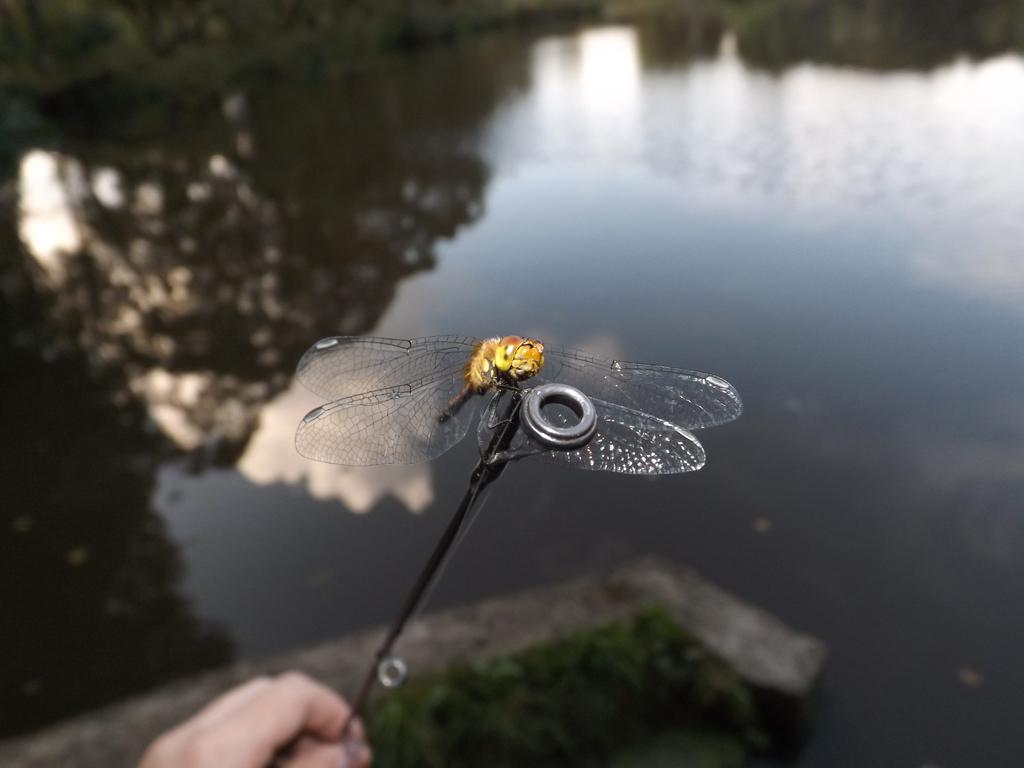Who or what is in the image? There is a person in the image. What is the person holding? The person is holding an object. Can you describe the object? A dragonfly is on the object. What is in front of the person? There is a lake in front of the person. What else can be seen in the image? There are plants visible in the image. What type of leather is the person wearing in the image? There is no mention of leather or any clothing in the image, so it cannot be determined what type of leather the person might be wearing. 